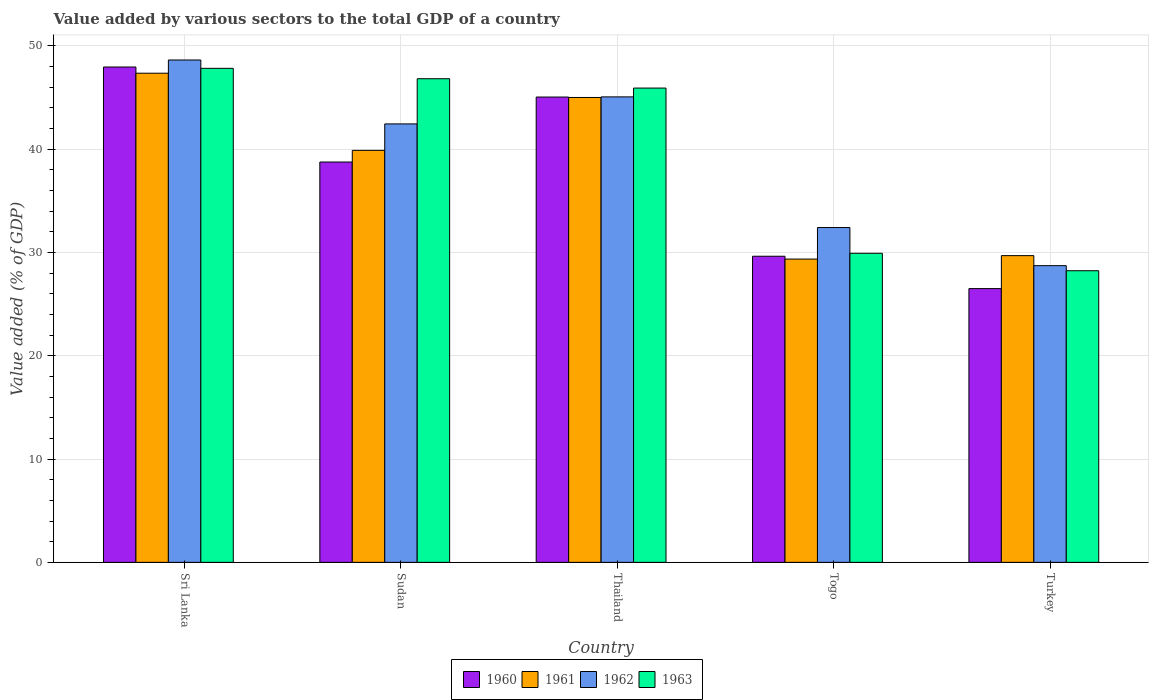How many groups of bars are there?
Offer a terse response. 5. Are the number of bars per tick equal to the number of legend labels?
Offer a very short reply. Yes. Are the number of bars on each tick of the X-axis equal?
Make the answer very short. Yes. How many bars are there on the 4th tick from the left?
Give a very brief answer. 4. How many bars are there on the 2nd tick from the right?
Give a very brief answer. 4. What is the label of the 2nd group of bars from the left?
Offer a very short reply. Sudan. What is the value added by various sectors to the total GDP in 1961 in Sri Lanka?
Ensure brevity in your answer.  47.35. Across all countries, what is the maximum value added by various sectors to the total GDP in 1963?
Make the answer very short. 47.82. Across all countries, what is the minimum value added by various sectors to the total GDP in 1961?
Offer a very short reply. 29.35. In which country was the value added by various sectors to the total GDP in 1960 maximum?
Keep it short and to the point. Sri Lanka. In which country was the value added by various sectors to the total GDP in 1962 minimum?
Provide a succinct answer. Turkey. What is the total value added by various sectors to the total GDP in 1961 in the graph?
Ensure brevity in your answer.  191.26. What is the difference between the value added by various sectors to the total GDP in 1962 in Sudan and that in Thailand?
Make the answer very short. -2.62. What is the difference between the value added by various sectors to the total GDP in 1963 in Sri Lanka and the value added by various sectors to the total GDP in 1960 in Turkey?
Your answer should be very brief. 21.32. What is the average value added by various sectors to the total GDP in 1960 per country?
Keep it short and to the point. 37.57. What is the difference between the value added by various sectors to the total GDP of/in 1960 and value added by various sectors to the total GDP of/in 1963 in Sudan?
Provide a short and direct response. -8.06. In how many countries, is the value added by various sectors to the total GDP in 1960 greater than 6 %?
Provide a succinct answer. 5. What is the ratio of the value added by various sectors to the total GDP in 1961 in Sudan to that in Togo?
Ensure brevity in your answer.  1.36. Is the value added by various sectors to the total GDP in 1961 in Sri Lanka less than that in Thailand?
Your answer should be very brief. No. What is the difference between the highest and the second highest value added by various sectors to the total GDP in 1962?
Provide a succinct answer. 6.19. What is the difference between the highest and the lowest value added by various sectors to the total GDP in 1960?
Your answer should be very brief. 21.45. Is the sum of the value added by various sectors to the total GDP in 1962 in Sri Lanka and Togo greater than the maximum value added by various sectors to the total GDP in 1960 across all countries?
Provide a short and direct response. Yes. Is it the case that in every country, the sum of the value added by various sectors to the total GDP in 1960 and value added by various sectors to the total GDP in 1962 is greater than the sum of value added by various sectors to the total GDP in 1963 and value added by various sectors to the total GDP in 1961?
Your answer should be very brief. No. What does the 3rd bar from the left in Sudan represents?
Give a very brief answer. 1962. What does the 2nd bar from the right in Sudan represents?
Ensure brevity in your answer.  1962. How many bars are there?
Make the answer very short. 20. How many countries are there in the graph?
Give a very brief answer. 5. What is the difference between two consecutive major ticks on the Y-axis?
Provide a short and direct response. 10. Are the values on the major ticks of Y-axis written in scientific E-notation?
Keep it short and to the point. No. Does the graph contain any zero values?
Keep it short and to the point. No. Does the graph contain grids?
Offer a very short reply. Yes. Where does the legend appear in the graph?
Make the answer very short. Bottom center. What is the title of the graph?
Offer a very short reply. Value added by various sectors to the total GDP of a country. Does "1998" appear as one of the legend labels in the graph?
Offer a terse response. No. What is the label or title of the X-axis?
Offer a very short reply. Country. What is the label or title of the Y-axis?
Provide a short and direct response. Value added (% of GDP). What is the Value added (% of GDP) of 1960 in Sri Lanka?
Give a very brief answer. 47.95. What is the Value added (% of GDP) of 1961 in Sri Lanka?
Make the answer very short. 47.35. What is the Value added (% of GDP) in 1962 in Sri Lanka?
Give a very brief answer. 48.62. What is the Value added (% of GDP) in 1963 in Sri Lanka?
Your response must be concise. 47.82. What is the Value added (% of GDP) of 1960 in Sudan?
Make the answer very short. 38.75. What is the Value added (% of GDP) of 1961 in Sudan?
Keep it short and to the point. 39.88. What is the Value added (% of GDP) in 1962 in Sudan?
Your answer should be very brief. 42.44. What is the Value added (% of GDP) of 1963 in Sudan?
Make the answer very short. 46.81. What is the Value added (% of GDP) in 1960 in Thailand?
Your response must be concise. 45.04. What is the Value added (% of GDP) of 1961 in Thailand?
Make the answer very short. 45. What is the Value added (% of GDP) in 1962 in Thailand?
Provide a succinct answer. 45.05. What is the Value added (% of GDP) of 1963 in Thailand?
Ensure brevity in your answer.  45.91. What is the Value added (% of GDP) in 1960 in Togo?
Keep it short and to the point. 29.63. What is the Value added (% of GDP) of 1961 in Togo?
Provide a succinct answer. 29.35. What is the Value added (% of GDP) of 1962 in Togo?
Offer a terse response. 32.41. What is the Value added (% of GDP) of 1963 in Togo?
Your response must be concise. 29.91. What is the Value added (% of GDP) in 1960 in Turkey?
Give a very brief answer. 26.5. What is the Value added (% of GDP) of 1961 in Turkey?
Your response must be concise. 29.69. What is the Value added (% of GDP) of 1962 in Turkey?
Provide a succinct answer. 28.72. What is the Value added (% of GDP) of 1963 in Turkey?
Your answer should be very brief. 28.23. Across all countries, what is the maximum Value added (% of GDP) in 1960?
Your answer should be very brief. 47.95. Across all countries, what is the maximum Value added (% of GDP) in 1961?
Provide a succinct answer. 47.35. Across all countries, what is the maximum Value added (% of GDP) in 1962?
Give a very brief answer. 48.62. Across all countries, what is the maximum Value added (% of GDP) in 1963?
Your response must be concise. 47.82. Across all countries, what is the minimum Value added (% of GDP) of 1960?
Offer a very short reply. 26.5. Across all countries, what is the minimum Value added (% of GDP) in 1961?
Give a very brief answer. 29.35. Across all countries, what is the minimum Value added (% of GDP) of 1962?
Offer a very short reply. 28.72. Across all countries, what is the minimum Value added (% of GDP) of 1963?
Give a very brief answer. 28.23. What is the total Value added (% of GDP) of 1960 in the graph?
Provide a succinct answer. 187.86. What is the total Value added (% of GDP) in 1961 in the graph?
Your answer should be compact. 191.26. What is the total Value added (% of GDP) of 1962 in the graph?
Your answer should be very brief. 197.24. What is the total Value added (% of GDP) of 1963 in the graph?
Ensure brevity in your answer.  198.68. What is the difference between the Value added (% of GDP) of 1960 in Sri Lanka and that in Sudan?
Your answer should be compact. 9.2. What is the difference between the Value added (% of GDP) of 1961 in Sri Lanka and that in Sudan?
Offer a terse response. 7.47. What is the difference between the Value added (% of GDP) of 1962 in Sri Lanka and that in Sudan?
Your response must be concise. 6.19. What is the difference between the Value added (% of GDP) in 1960 in Sri Lanka and that in Thailand?
Your answer should be very brief. 2.91. What is the difference between the Value added (% of GDP) in 1961 in Sri Lanka and that in Thailand?
Offer a terse response. 2.35. What is the difference between the Value added (% of GDP) in 1962 in Sri Lanka and that in Thailand?
Your response must be concise. 3.57. What is the difference between the Value added (% of GDP) of 1963 in Sri Lanka and that in Thailand?
Provide a short and direct response. 1.91. What is the difference between the Value added (% of GDP) of 1960 in Sri Lanka and that in Togo?
Keep it short and to the point. 18.32. What is the difference between the Value added (% of GDP) of 1961 in Sri Lanka and that in Togo?
Make the answer very short. 17.99. What is the difference between the Value added (% of GDP) in 1962 in Sri Lanka and that in Togo?
Keep it short and to the point. 16.22. What is the difference between the Value added (% of GDP) of 1963 in Sri Lanka and that in Togo?
Offer a very short reply. 17.9. What is the difference between the Value added (% of GDP) in 1960 in Sri Lanka and that in Turkey?
Give a very brief answer. 21.45. What is the difference between the Value added (% of GDP) of 1961 in Sri Lanka and that in Turkey?
Offer a very short reply. 17.66. What is the difference between the Value added (% of GDP) of 1962 in Sri Lanka and that in Turkey?
Make the answer very short. 19.91. What is the difference between the Value added (% of GDP) in 1963 in Sri Lanka and that in Turkey?
Provide a succinct answer. 19.59. What is the difference between the Value added (% of GDP) in 1960 in Sudan and that in Thailand?
Offer a terse response. -6.29. What is the difference between the Value added (% of GDP) of 1961 in Sudan and that in Thailand?
Make the answer very short. -5.12. What is the difference between the Value added (% of GDP) in 1962 in Sudan and that in Thailand?
Provide a succinct answer. -2.62. What is the difference between the Value added (% of GDP) in 1963 in Sudan and that in Thailand?
Keep it short and to the point. 0.9. What is the difference between the Value added (% of GDP) in 1960 in Sudan and that in Togo?
Keep it short and to the point. 9.12. What is the difference between the Value added (% of GDP) in 1961 in Sudan and that in Togo?
Give a very brief answer. 10.52. What is the difference between the Value added (% of GDP) of 1962 in Sudan and that in Togo?
Provide a succinct answer. 10.03. What is the difference between the Value added (% of GDP) of 1963 in Sudan and that in Togo?
Provide a succinct answer. 16.9. What is the difference between the Value added (% of GDP) of 1960 in Sudan and that in Turkey?
Give a very brief answer. 12.25. What is the difference between the Value added (% of GDP) in 1961 in Sudan and that in Turkey?
Your response must be concise. 10.19. What is the difference between the Value added (% of GDP) in 1962 in Sudan and that in Turkey?
Keep it short and to the point. 13.72. What is the difference between the Value added (% of GDP) of 1963 in Sudan and that in Turkey?
Provide a succinct answer. 18.58. What is the difference between the Value added (% of GDP) of 1960 in Thailand and that in Togo?
Your answer should be very brief. 15.41. What is the difference between the Value added (% of GDP) in 1961 in Thailand and that in Togo?
Ensure brevity in your answer.  15.64. What is the difference between the Value added (% of GDP) in 1962 in Thailand and that in Togo?
Your answer should be very brief. 12.65. What is the difference between the Value added (% of GDP) of 1963 in Thailand and that in Togo?
Offer a very short reply. 15.99. What is the difference between the Value added (% of GDP) of 1960 in Thailand and that in Turkey?
Offer a very short reply. 18.54. What is the difference between the Value added (% of GDP) in 1961 in Thailand and that in Turkey?
Your answer should be compact. 15.31. What is the difference between the Value added (% of GDP) of 1962 in Thailand and that in Turkey?
Provide a short and direct response. 16.34. What is the difference between the Value added (% of GDP) in 1963 in Thailand and that in Turkey?
Keep it short and to the point. 17.68. What is the difference between the Value added (% of GDP) in 1960 in Togo and that in Turkey?
Keep it short and to the point. 3.13. What is the difference between the Value added (% of GDP) of 1961 in Togo and that in Turkey?
Your response must be concise. -0.33. What is the difference between the Value added (% of GDP) in 1962 in Togo and that in Turkey?
Your answer should be compact. 3.69. What is the difference between the Value added (% of GDP) in 1963 in Togo and that in Turkey?
Provide a short and direct response. 1.69. What is the difference between the Value added (% of GDP) of 1960 in Sri Lanka and the Value added (% of GDP) of 1961 in Sudan?
Give a very brief answer. 8.07. What is the difference between the Value added (% of GDP) in 1960 in Sri Lanka and the Value added (% of GDP) in 1962 in Sudan?
Give a very brief answer. 5.51. What is the difference between the Value added (% of GDP) in 1960 in Sri Lanka and the Value added (% of GDP) in 1963 in Sudan?
Offer a terse response. 1.14. What is the difference between the Value added (% of GDP) in 1961 in Sri Lanka and the Value added (% of GDP) in 1962 in Sudan?
Provide a succinct answer. 4.91. What is the difference between the Value added (% of GDP) of 1961 in Sri Lanka and the Value added (% of GDP) of 1963 in Sudan?
Provide a succinct answer. 0.53. What is the difference between the Value added (% of GDP) in 1962 in Sri Lanka and the Value added (% of GDP) in 1963 in Sudan?
Offer a terse response. 1.81. What is the difference between the Value added (% of GDP) of 1960 in Sri Lanka and the Value added (% of GDP) of 1961 in Thailand?
Provide a short and direct response. 2.95. What is the difference between the Value added (% of GDP) of 1960 in Sri Lanka and the Value added (% of GDP) of 1962 in Thailand?
Keep it short and to the point. 2.89. What is the difference between the Value added (% of GDP) in 1960 in Sri Lanka and the Value added (% of GDP) in 1963 in Thailand?
Give a very brief answer. 2.04. What is the difference between the Value added (% of GDP) of 1961 in Sri Lanka and the Value added (% of GDP) of 1962 in Thailand?
Ensure brevity in your answer.  2.29. What is the difference between the Value added (% of GDP) of 1961 in Sri Lanka and the Value added (% of GDP) of 1963 in Thailand?
Your response must be concise. 1.44. What is the difference between the Value added (% of GDP) in 1962 in Sri Lanka and the Value added (% of GDP) in 1963 in Thailand?
Offer a terse response. 2.72. What is the difference between the Value added (% of GDP) of 1960 in Sri Lanka and the Value added (% of GDP) of 1961 in Togo?
Your response must be concise. 18.59. What is the difference between the Value added (% of GDP) of 1960 in Sri Lanka and the Value added (% of GDP) of 1962 in Togo?
Offer a very short reply. 15.54. What is the difference between the Value added (% of GDP) of 1960 in Sri Lanka and the Value added (% of GDP) of 1963 in Togo?
Ensure brevity in your answer.  18.03. What is the difference between the Value added (% of GDP) in 1961 in Sri Lanka and the Value added (% of GDP) in 1962 in Togo?
Your answer should be compact. 14.94. What is the difference between the Value added (% of GDP) of 1961 in Sri Lanka and the Value added (% of GDP) of 1963 in Togo?
Keep it short and to the point. 17.43. What is the difference between the Value added (% of GDP) of 1962 in Sri Lanka and the Value added (% of GDP) of 1963 in Togo?
Make the answer very short. 18.71. What is the difference between the Value added (% of GDP) in 1960 in Sri Lanka and the Value added (% of GDP) in 1961 in Turkey?
Provide a succinct answer. 18.26. What is the difference between the Value added (% of GDP) in 1960 in Sri Lanka and the Value added (% of GDP) in 1962 in Turkey?
Offer a very short reply. 19.23. What is the difference between the Value added (% of GDP) in 1960 in Sri Lanka and the Value added (% of GDP) in 1963 in Turkey?
Provide a short and direct response. 19.72. What is the difference between the Value added (% of GDP) in 1961 in Sri Lanka and the Value added (% of GDP) in 1962 in Turkey?
Your answer should be very brief. 18.63. What is the difference between the Value added (% of GDP) in 1961 in Sri Lanka and the Value added (% of GDP) in 1963 in Turkey?
Make the answer very short. 19.12. What is the difference between the Value added (% of GDP) of 1962 in Sri Lanka and the Value added (% of GDP) of 1963 in Turkey?
Provide a succinct answer. 20.4. What is the difference between the Value added (% of GDP) in 1960 in Sudan and the Value added (% of GDP) in 1961 in Thailand?
Keep it short and to the point. -6.25. What is the difference between the Value added (% of GDP) in 1960 in Sudan and the Value added (% of GDP) in 1962 in Thailand?
Offer a terse response. -6.31. What is the difference between the Value added (% of GDP) of 1960 in Sudan and the Value added (% of GDP) of 1963 in Thailand?
Provide a short and direct response. -7.16. What is the difference between the Value added (% of GDP) in 1961 in Sudan and the Value added (% of GDP) in 1962 in Thailand?
Provide a succinct answer. -5.18. What is the difference between the Value added (% of GDP) in 1961 in Sudan and the Value added (% of GDP) in 1963 in Thailand?
Ensure brevity in your answer.  -6.03. What is the difference between the Value added (% of GDP) in 1962 in Sudan and the Value added (% of GDP) in 1963 in Thailand?
Offer a terse response. -3.47. What is the difference between the Value added (% of GDP) in 1960 in Sudan and the Value added (% of GDP) in 1961 in Togo?
Offer a terse response. 9.39. What is the difference between the Value added (% of GDP) in 1960 in Sudan and the Value added (% of GDP) in 1962 in Togo?
Your answer should be compact. 6.34. What is the difference between the Value added (% of GDP) in 1960 in Sudan and the Value added (% of GDP) in 1963 in Togo?
Your answer should be compact. 8.83. What is the difference between the Value added (% of GDP) of 1961 in Sudan and the Value added (% of GDP) of 1962 in Togo?
Your answer should be compact. 7.47. What is the difference between the Value added (% of GDP) of 1961 in Sudan and the Value added (% of GDP) of 1963 in Togo?
Make the answer very short. 9.96. What is the difference between the Value added (% of GDP) of 1962 in Sudan and the Value added (% of GDP) of 1963 in Togo?
Make the answer very short. 12.52. What is the difference between the Value added (% of GDP) in 1960 in Sudan and the Value added (% of GDP) in 1961 in Turkey?
Your response must be concise. 9.06. What is the difference between the Value added (% of GDP) in 1960 in Sudan and the Value added (% of GDP) in 1962 in Turkey?
Make the answer very short. 10.03. What is the difference between the Value added (% of GDP) of 1960 in Sudan and the Value added (% of GDP) of 1963 in Turkey?
Ensure brevity in your answer.  10.52. What is the difference between the Value added (% of GDP) in 1961 in Sudan and the Value added (% of GDP) in 1962 in Turkey?
Provide a succinct answer. 11.16. What is the difference between the Value added (% of GDP) of 1961 in Sudan and the Value added (% of GDP) of 1963 in Turkey?
Offer a very short reply. 11.65. What is the difference between the Value added (% of GDP) of 1962 in Sudan and the Value added (% of GDP) of 1963 in Turkey?
Provide a short and direct response. 14.21. What is the difference between the Value added (% of GDP) of 1960 in Thailand and the Value added (% of GDP) of 1961 in Togo?
Your response must be concise. 15.68. What is the difference between the Value added (% of GDP) in 1960 in Thailand and the Value added (% of GDP) in 1962 in Togo?
Make the answer very short. 12.63. What is the difference between the Value added (% of GDP) in 1960 in Thailand and the Value added (% of GDP) in 1963 in Togo?
Make the answer very short. 15.12. What is the difference between the Value added (% of GDP) in 1961 in Thailand and the Value added (% of GDP) in 1962 in Togo?
Offer a very short reply. 12.59. What is the difference between the Value added (% of GDP) in 1961 in Thailand and the Value added (% of GDP) in 1963 in Togo?
Provide a succinct answer. 15.08. What is the difference between the Value added (% of GDP) of 1962 in Thailand and the Value added (% of GDP) of 1963 in Togo?
Give a very brief answer. 15.14. What is the difference between the Value added (% of GDP) in 1960 in Thailand and the Value added (% of GDP) in 1961 in Turkey?
Provide a short and direct response. 15.35. What is the difference between the Value added (% of GDP) of 1960 in Thailand and the Value added (% of GDP) of 1962 in Turkey?
Offer a very short reply. 16.32. What is the difference between the Value added (% of GDP) in 1960 in Thailand and the Value added (% of GDP) in 1963 in Turkey?
Offer a terse response. 16.81. What is the difference between the Value added (% of GDP) in 1961 in Thailand and the Value added (% of GDP) in 1962 in Turkey?
Your answer should be very brief. 16.28. What is the difference between the Value added (% of GDP) of 1961 in Thailand and the Value added (% of GDP) of 1963 in Turkey?
Your answer should be very brief. 16.77. What is the difference between the Value added (% of GDP) in 1962 in Thailand and the Value added (% of GDP) in 1963 in Turkey?
Offer a terse response. 16.83. What is the difference between the Value added (% of GDP) of 1960 in Togo and the Value added (% of GDP) of 1961 in Turkey?
Your answer should be very brief. -0.06. What is the difference between the Value added (% of GDP) of 1960 in Togo and the Value added (% of GDP) of 1962 in Turkey?
Offer a very short reply. 0.91. What is the difference between the Value added (% of GDP) of 1960 in Togo and the Value added (% of GDP) of 1963 in Turkey?
Provide a succinct answer. 1.4. What is the difference between the Value added (% of GDP) of 1961 in Togo and the Value added (% of GDP) of 1962 in Turkey?
Provide a short and direct response. 0.64. What is the difference between the Value added (% of GDP) in 1961 in Togo and the Value added (% of GDP) in 1963 in Turkey?
Your response must be concise. 1.13. What is the difference between the Value added (% of GDP) of 1962 in Togo and the Value added (% of GDP) of 1963 in Turkey?
Your answer should be very brief. 4.18. What is the average Value added (% of GDP) of 1960 per country?
Offer a very short reply. 37.57. What is the average Value added (% of GDP) in 1961 per country?
Your answer should be compact. 38.25. What is the average Value added (% of GDP) of 1962 per country?
Offer a very short reply. 39.45. What is the average Value added (% of GDP) in 1963 per country?
Offer a terse response. 39.74. What is the difference between the Value added (% of GDP) of 1960 and Value added (% of GDP) of 1961 in Sri Lanka?
Your answer should be compact. 0.6. What is the difference between the Value added (% of GDP) in 1960 and Value added (% of GDP) in 1962 in Sri Lanka?
Your response must be concise. -0.68. What is the difference between the Value added (% of GDP) of 1960 and Value added (% of GDP) of 1963 in Sri Lanka?
Your answer should be very brief. 0.13. What is the difference between the Value added (% of GDP) in 1961 and Value added (% of GDP) in 1962 in Sri Lanka?
Make the answer very short. -1.28. What is the difference between the Value added (% of GDP) in 1961 and Value added (% of GDP) in 1963 in Sri Lanka?
Offer a terse response. -0.47. What is the difference between the Value added (% of GDP) of 1962 and Value added (% of GDP) of 1963 in Sri Lanka?
Your answer should be compact. 0.81. What is the difference between the Value added (% of GDP) in 1960 and Value added (% of GDP) in 1961 in Sudan?
Your answer should be compact. -1.13. What is the difference between the Value added (% of GDP) in 1960 and Value added (% of GDP) in 1962 in Sudan?
Offer a terse response. -3.69. What is the difference between the Value added (% of GDP) of 1960 and Value added (% of GDP) of 1963 in Sudan?
Your response must be concise. -8.06. What is the difference between the Value added (% of GDP) of 1961 and Value added (% of GDP) of 1962 in Sudan?
Your response must be concise. -2.56. What is the difference between the Value added (% of GDP) in 1961 and Value added (% of GDP) in 1963 in Sudan?
Ensure brevity in your answer.  -6.93. What is the difference between the Value added (% of GDP) in 1962 and Value added (% of GDP) in 1963 in Sudan?
Offer a terse response. -4.37. What is the difference between the Value added (% of GDP) of 1960 and Value added (% of GDP) of 1961 in Thailand?
Offer a terse response. 0.04. What is the difference between the Value added (% of GDP) of 1960 and Value added (% of GDP) of 1962 in Thailand?
Your response must be concise. -0.02. What is the difference between the Value added (% of GDP) in 1960 and Value added (% of GDP) in 1963 in Thailand?
Offer a terse response. -0.87. What is the difference between the Value added (% of GDP) of 1961 and Value added (% of GDP) of 1962 in Thailand?
Keep it short and to the point. -0.06. What is the difference between the Value added (% of GDP) of 1961 and Value added (% of GDP) of 1963 in Thailand?
Your answer should be very brief. -0.91. What is the difference between the Value added (% of GDP) in 1962 and Value added (% of GDP) in 1963 in Thailand?
Provide a succinct answer. -0.85. What is the difference between the Value added (% of GDP) in 1960 and Value added (% of GDP) in 1961 in Togo?
Provide a short and direct response. 0.27. What is the difference between the Value added (% of GDP) in 1960 and Value added (% of GDP) in 1962 in Togo?
Give a very brief answer. -2.78. What is the difference between the Value added (% of GDP) of 1960 and Value added (% of GDP) of 1963 in Togo?
Your response must be concise. -0.28. What is the difference between the Value added (% of GDP) of 1961 and Value added (% of GDP) of 1962 in Togo?
Your answer should be compact. -3.05. What is the difference between the Value added (% of GDP) in 1961 and Value added (% of GDP) in 1963 in Togo?
Your answer should be very brief. -0.56. What is the difference between the Value added (% of GDP) of 1962 and Value added (% of GDP) of 1963 in Togo?
Provide a succinct answer. 2.49. What is the difference between the Value added (% of GDP) of 1960 and Value added (% of GDP) of 1961 in Turkey?
Give a very brief answer. -3.19. What is the difference between the Value added (% of GDP) in 1960 and Value added (% of GDP) in 1962 in Turkey?
Your response must be concise. -2.22. What is the difference between the Value added (% of GDP) of 1960 and Value added (% of GDP) of 1963 in Turkey?
Give a very brief answer. -1.73. What is the difference between the Value added (% of GDP) of 1961 and Value added (% of GDP) of 1962 in Turkey?
Keep it short and to the point. 0.97. What is the difference between the Value added (% of GDP) in 1961 and Value added (% of GDP) in 1963 in Turkey?
Offer a terse response. 1.46. What is the difference between the Value added (% of GDP) of 1962 and Value added (% of GDP) of 1963 in Turkey?
Offer a very short reply. 0.49. What is the ratio of the Value added (% of GDP) in 1960 in Sri Lanka to that in Sudan?
Give a very brief answer. 1.24. What is the ratio of the Value added (% of GDP) of 1961 in Sri Lanka to that in Sudan?
Your answer should be very brief. 1.19. What is the ratio of the Value added (% of GDP) of 1962 in Sri Lanka to that in Sudan?
Provide a succinct answer. 1.15. What is the ratio of the Value added (% of GDP) in 1963 in Sri Lanka to that in Sudan?
Your answer should be very brief. 1.02. What is the ratio of the Value added (% of GDP) in 1960 in Sri Lanka to that in Thailand?
Offer a terse response. 1.06. What is the ratio of the Value added (% of GDP) of 1961 in Sri Lanka to that in Thailand?
Your answer should be compact. 1.05. What is the ratio of the Value added (% of GDP) in 1962 in Sri Lanka to that in Thailand?
Your answer should be very brief. 1.08. What is the ratio of the Value added (% of GDP) of 1963 in Sri Lanka to that in Thailand?
Your response must be concise. 1.04. What is the ratio of the Value added (% of GDP) of 1960 in Sri Lanka to that in Togo?
Ensure brevity in your answer.  1.62. What is the ratio of the Value added (% of GDP) of 1961 in Sri Lanka to that in Togo?
Make the answer very short. 1.61. What is the ratio of the Value added (% of GDP) in 1962 in Sri Lanka to that in Togo?
Keep it short and to the point. 1.5. What is the ratio of the Value added (% of GDP) of 1963 in Sri Lanka to that in Togo?
Provide a succinct answer. 1.6. What is the ratio of the Value added (% of GDP) of 1960 in Sri Lanka to that in Turkey?
Your answer should be compact. 1.81. What is the ratio of the Value added (% of GDP) of 1961 in Sri Lanka to that in Turkey?
Offer a very short reply. 1.59. What is the ratio of the Value added (% of GDP) in 1962 in Sri Lanka to that in Turkey?
Offer a terse response. 1.69. What is the ratio of the Value added (% of GDP) in 1963 in Sri Lanka to that in Turkey?
Your response must be concise. 1.69. What is the ratio of the Value added (% of GDP) of 1960 in Sudan to that in Thailand?
Give a very brief answer. 0.86. What is the ratio of the Value added (% of GDP) of 1961 in Sudan to that in Thailand?
Provide a succinct answer. 0.89. What is the ratio of the Value added (% of GDP) in 1962 in Sudan to that in Thailand?
Offer a very short reply. 0.94. What is the ratio of the Value added (% of GDP) in 1963 in Sudan to that in Thailand?
Give a very brief answer. 1.02. What is the ratio of the Value added (% of GDP) in 1960 in Sudan to that in Togo?
Offer a very short reply. 1.31. What is the ratio of the Value added (% of GDP) of 1961 in Sudan to that in Togo?
Your response must be concise. 1.36. What is the ratio of the Value added (% of GDP) of 1962 in Sudan to that in Togo?
Your response must be concise. 1.31. What is the ratio of the Value added (% of GDP) in 1963 in Sudan to that in Togo?
Your answer should be very brief. 1.56. What is the ratio of the Value added (% of GDP) in 1960 in Sudan to that in Turkey?
Ensure brevity in your answer.  1.46. What is the ratio of the Value added (% of GDP) in 1961 in Sudan to that in Turkey?
Your answer should be compact. 1.34. What is the ratio of the Value added (% of GDP) of 1962 in Sudan to that in Turkey?
Your answer should be compact. 1.48. What is the ratio of the Value added (% of GDP) in 1963 in Sudan to that in Turkey?
Give a very brief answer. 1.66. What is the ratio of the Value added (% of GDP) in 1960 in Thailand to that in Togo?
Your response must be concise. 1.52. What is the ratio of the Value added (% of GDP) of 1961 in Thailand to that in Togo?
Provide a succinct answer. 1.53. What is the ratio of the Value added (% of GDP) in 1962 in Thailand to that in Togo?
Your answer should be very brief. 1.39. What is the ratio of the Value added (% of GDP) of 1963 in Thailand to that in Togo?
Offer a terse response. 1.53. What is the ratio of the Value added (% of GDP) in 1960 in Thailand to that in Turkey?
Your answer should be compact. 1.7. What is the ratio of the Value added (% of GDP) of 1961 in Thailand to that in Turkey?
Your answer should be very brief. 1.52. What is the ratio of the Value added (% of GDP) of 1962 in Thailand to that in Turkey?
Offer a terse response. 1.57. What is the ratio of the Value added (% of GDP) of 1963 in Thailand to that in Turkey?
Provide a succinct answer. 1.63. What is the ratio of the Value added (% of GDP) of 1960 in Togo to that in Turkey?
Offer a very short reply. 1.12. What is the ratio of the Value added (% of GDP) of 1961 in Togo to that in Turkey?
Your answer should be very brief. 0.99. What is the ratio of the Value added (% of GDP) of 1962 in Togo to that in Turkey?
Your response must be concise. 1.13. What is the ratio of the Value added (% of GDP) of 1963 in Togo to that in Turkey?
Give a very brief answer. 1.06. What is the difference between the highest and the second highest Value added (% of GDP) in 1960?
Ensure brevity in your answer.  2.91. What is the difference between the highest and the second highest Value added (% of GDP) in 1961?
Offer a very short reply. 2.35. What is the difference between the highest and the second highest Value added (% of GDP) of 1962?
Make the answer very short. 3.57. What is the difference between the highest and the lowest Value added (% of GDP) of 1960?
Your answer should be compact. 21.45. What is the difference between the highest and the lowest Value added (% of GDP) of 1961?
Your answer should be compact. 17.99. What is the difference between the highest and the lowest Value added (% of GDP) of 1962?
Offer a very short reply. 19.91. What is the difference between the highest and the lowest Value added (% of GDP) of 1963?
Your answer should be very brief. 19.59. 